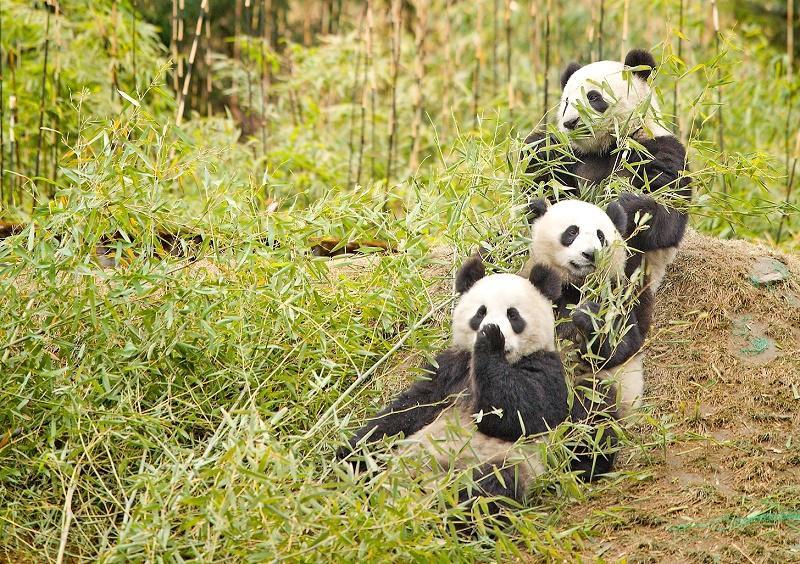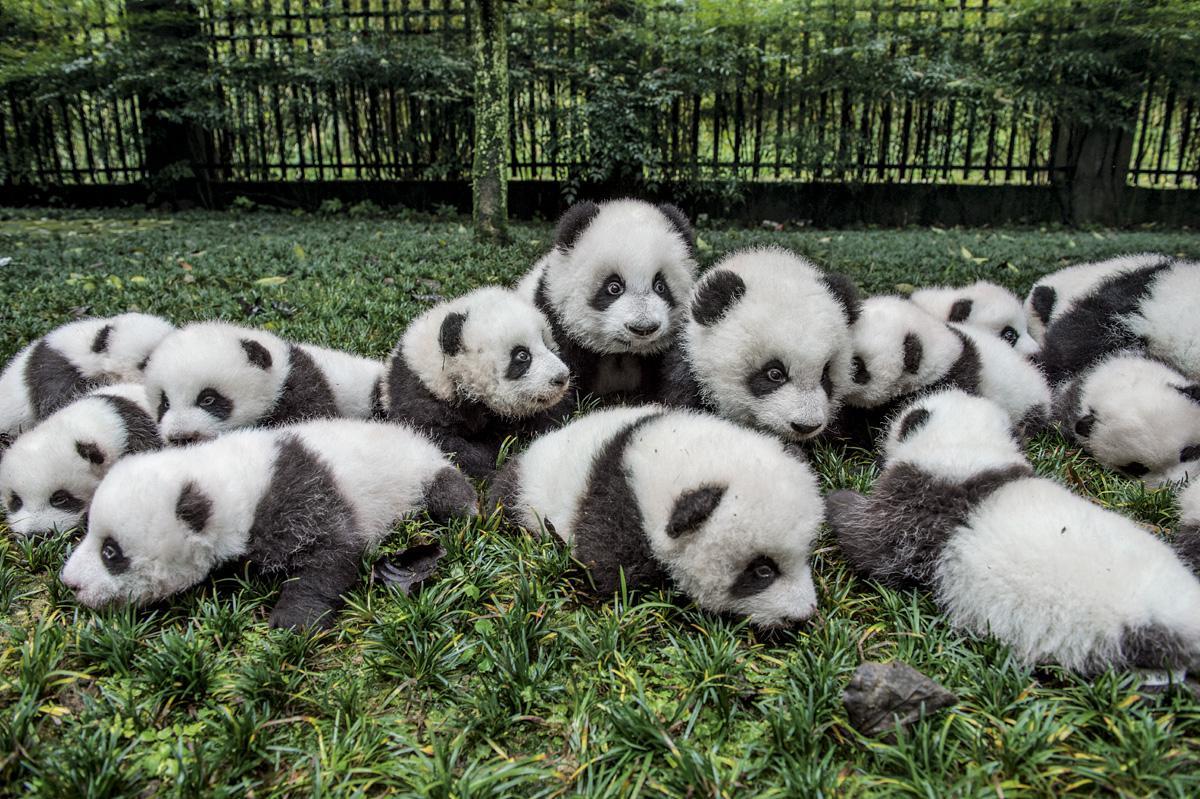The first image is the image on the left, the second image is the image on the right. Evaluate the accuracy of this statement regarding the images: "An image shows multiple pandas with green stalks for munching, on a structure of joined logs.". Is it true? Answer yes or no. No. The first image is the image on the left, the second image is the image on the right. Considering the images on both sides, is "At least one panda is sitting in an open grassy area in one of the images." valid? Answer yes or no. Yes. 